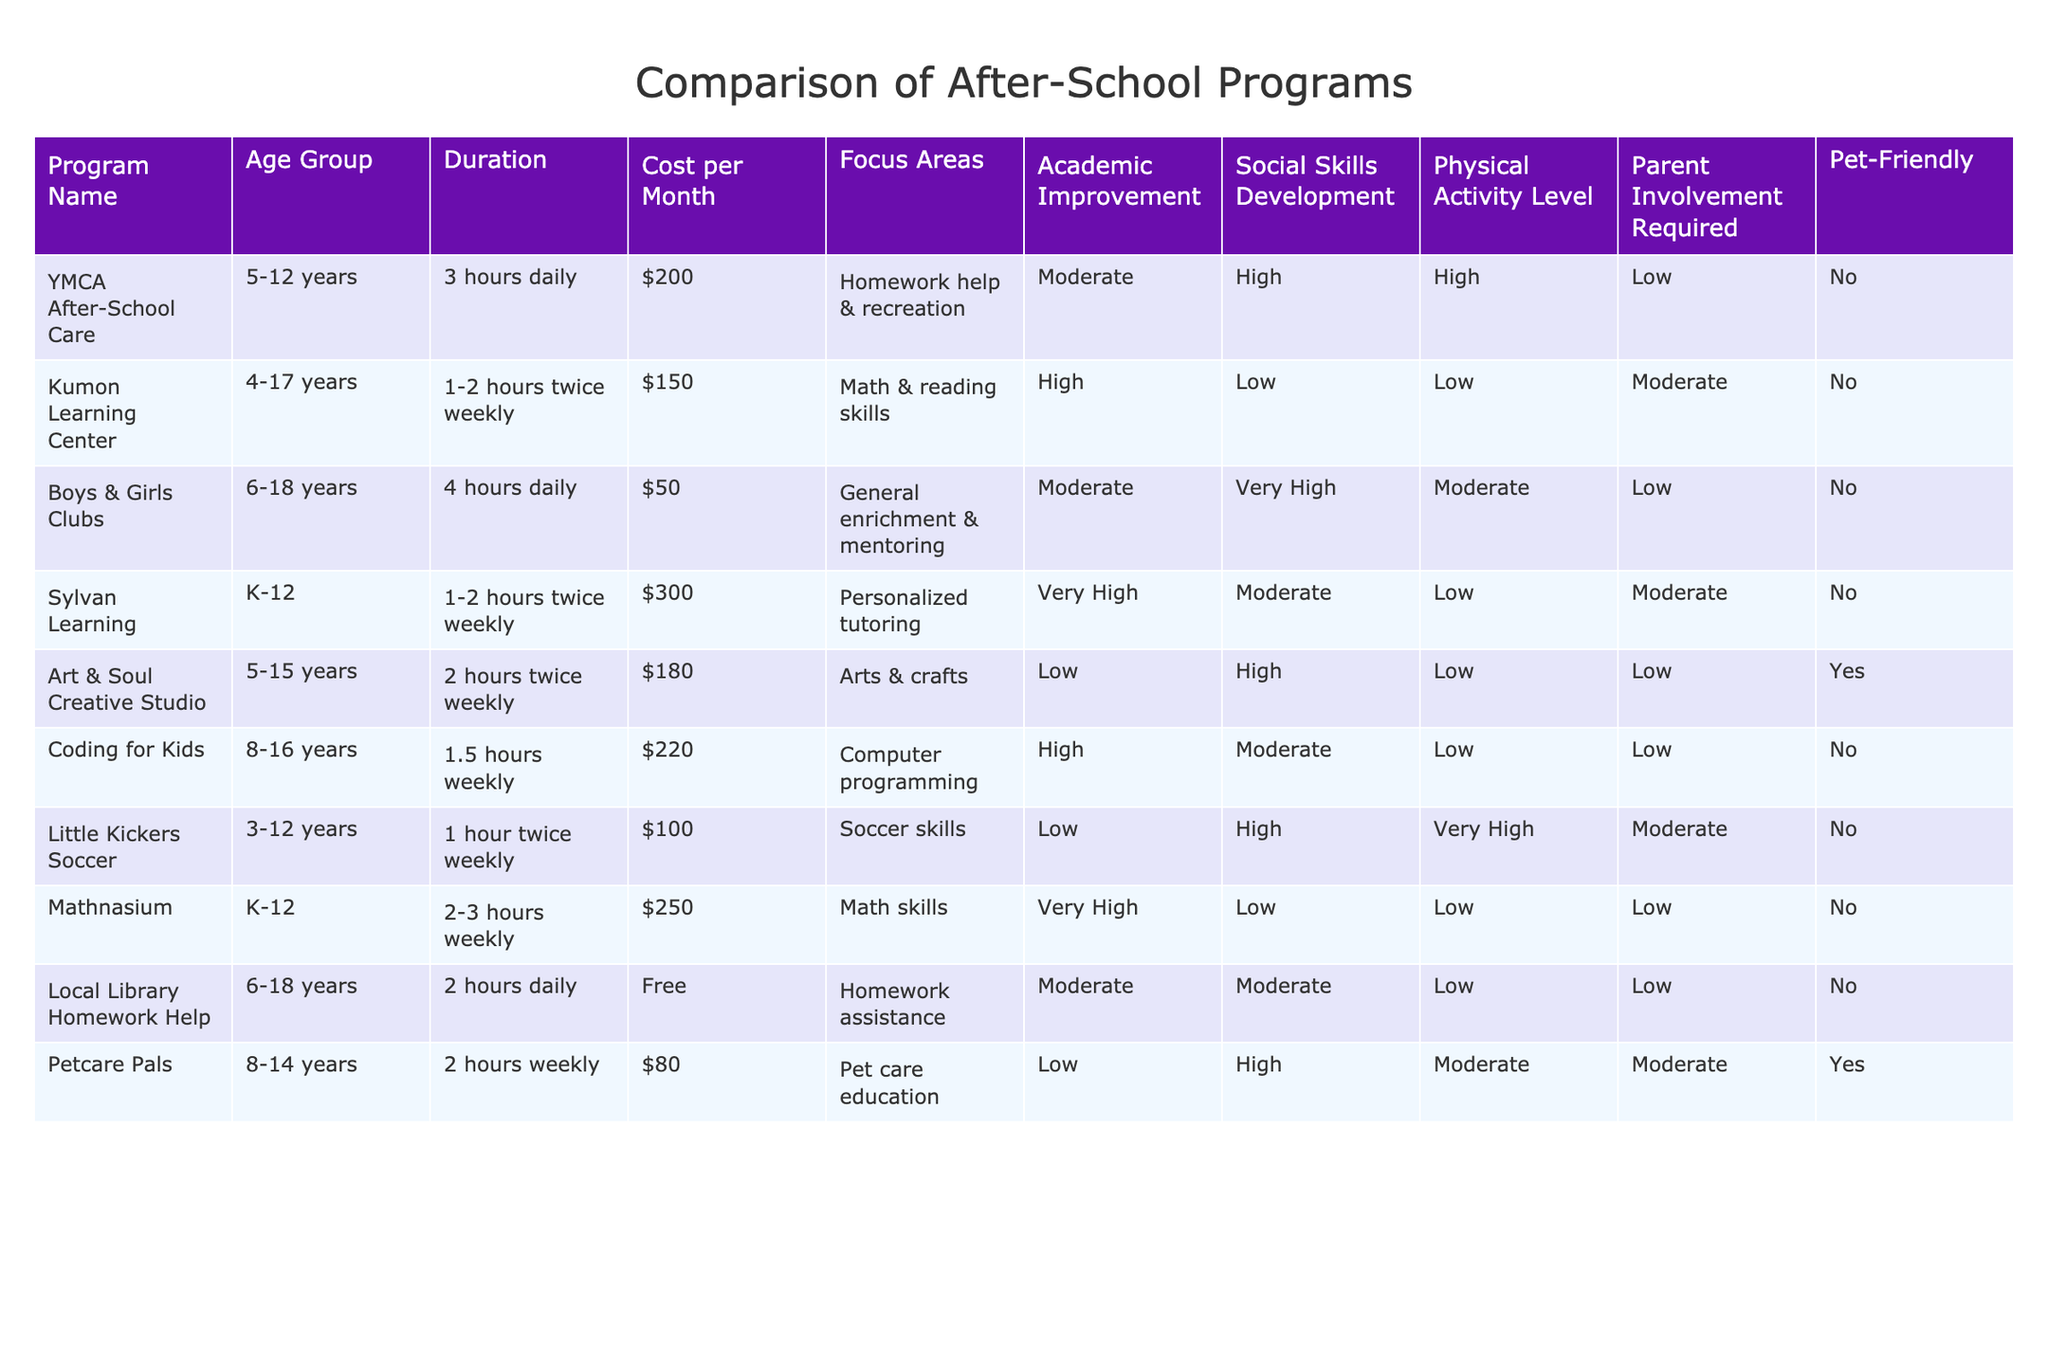What is the cost per month for the Coding for Kids program? The table shows that the cost per month for the Coding for Kids program is listed under the "Cost per Month" column, which is $220.
Answer: $220 Which program focuses on pet care education and is pet-friendly? Referring to the "Focus Areas" and "Pet-Friendly" columns, the program that focuses on pet care education and is pet-friendly is "Petcare Pals."
Answer: Petcare Pals What is the average cost of the programs that require moderate parent involvement? To find the average cost, first identify the programs that require moderate parent involvement: Kumon Learning Center ($150), Sylvan Learning ($300), Coding for Kids ($220), Petcare Pals ($80). Sum of these costs is 150 + 300 + 220 + 80 = 750. Divide by the number of programs (4), which gives 750 / 4 = 187.5.
Answer: $187.50 How many programs are there that offer high levels of social skills development? By examining the "Social Skills Development" column, I find that the programs categorized as having high levels of social skills development are YMCA After-School Care, Art & Soul Creative Studio, and Little Kickers Soccer. This totals to 3 programs.
Answer: 3 Is the Local Library Homework Help program pet-friendly? The "Pet-Friendly" column indicates that the Local Library Homework Help program is marked as "No," meaning it is not pet-friendly.
Answer: No Which program has the longest duration per day? From the "Duration" column, Boys & Girls Clubs offers 4 hours daily, which is the longest duration compared to others.
Answer: Boys & Girls Clubs What is the difference in academic improvement ratings between the Kumon Learning Center and Petcare Pals? The academic improvement rating for Kumon Learning Center is "High," and for Petcare Pals, it is "Low." The difference in levels is 1 level down from High to Low.
Answer: 1 level Which program is the most expensive and what is its focus area? The most expensive program according to the "Cost per Month" column is Sylvan Learning at $300, and its focus area is "Personalized tutoring."
Answer: Sylvan Learning, Personalized tutoring How many programs are designed for children aged 5-12 years? Checking the "Age Group" column, the programs designed for children aged 5-12 years include YMCA After-School Care, Art & Soul Creative Studio, and Little Kickers Soccer, totaling 3 programs.
Answer: 3 